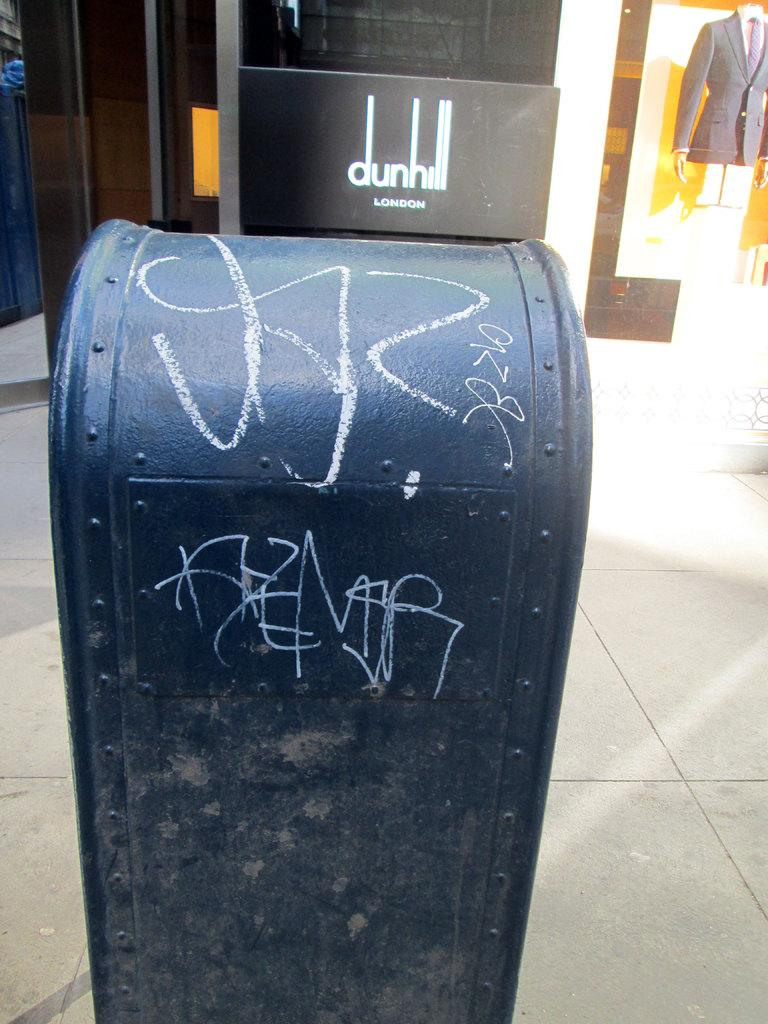<image>
Give a short and clear explanation of the subsequent image. A post office box sits on the sidewalk outside of dunhill store. 